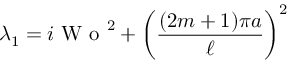Convert formula to latex. <formula><loc_0><loc_0><loc_500><loc_500>\lambda _ { 1 } = i W o ^ { 2 } + \left ( \frac { ( 2 m + 1 ) \pi a } { \ell } \right ) ^ { 2 }</formula> 